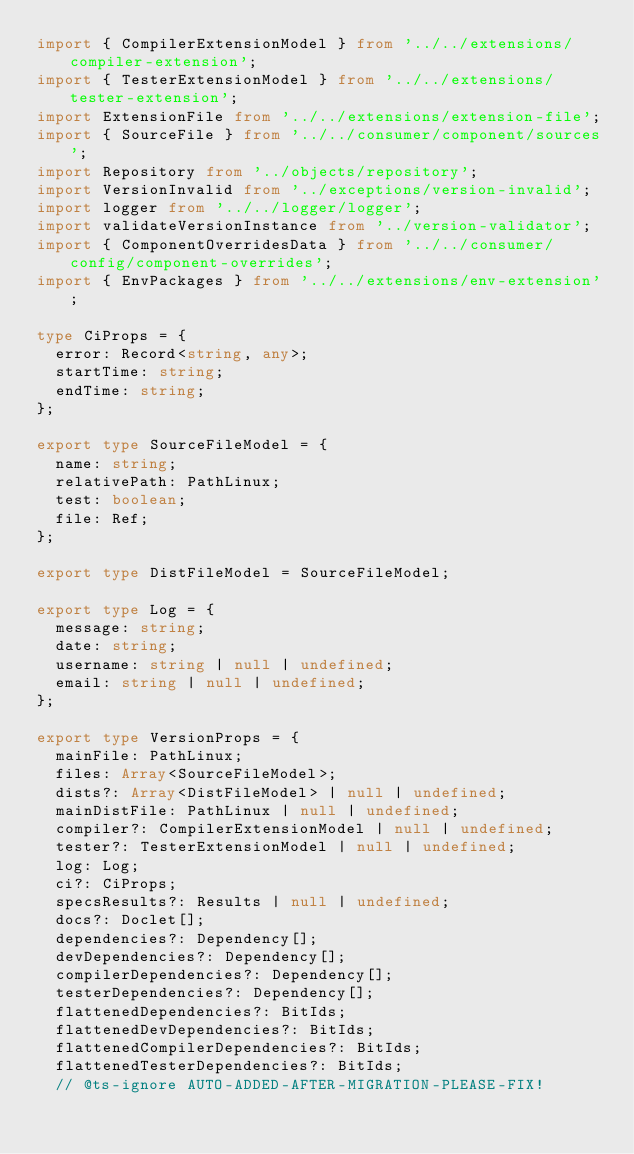<code> <loc_0><loc_0><loc_500><loc_500><_TypeScript_>import { CompilerExtensionModel } from '../../extensions/compiler-extension';
import { TesterExtensionModel } from '../../extensions/tester-extension';
import ExtensionFile from '../../extensions/extension-file';
import { SourceFile } from '../../consumer/component/sources';
import Repository from '../objects/repository';
import VersionInvalid from '../exceptions/version-invalid';
import logger from '../../logger/logger';
import validateVersionInstance from '../version-validator';
import { ComponentOverridesData } from '../../consumer/config/component-overrides';
import { EnvPackages } from '../../extensions/env-extension';

type CiProps = {
  error: Record<string, any>;
  startTime: string;
  endTime: string;
};

export type SourceFileModel = {
  name: string;
  relativePath: PathLinux;
  test: boolean;
  file: Ref;
};

export type DistFileModel = SourceFileModel;

export type Log = {
  message: string;
  date: string;
  username: string | null | undefined;
  email: string | null | undefined;
};

export type VersionProps = {
  mainFile: PathLinux;
  files: Array<SourceFileModel>;
  dists?: Array<DistFileModel> | null | undefined;
  mainDistFile: PathLinux | null | undefined;
  compiler?: CompilerExtensionModel | null | undefined;
  tester?: TesterExtensionModel | null | undefined;
  log: Log;
  ci?: CiProps;
  specsResults?: Results | null | undefined;
  docs?: Doclet[];
  dependencies?: Dependency[];
  devDependencies?: Dependency[];
  compilerDependencies?: Dependency[];
  testerDependencies?: Dependency[];
  flattenedDependencies?: BitIds;
  flattenedDevDependencies?: BitIds;
  flattenedCompilerDependencies?: BitIds;
  flattenedTesterDependencies?: BitIds;
  // @ts-ignore AUTO-ADDED-AFTER-MIGRATION-PLEASE-FIX!</code> 